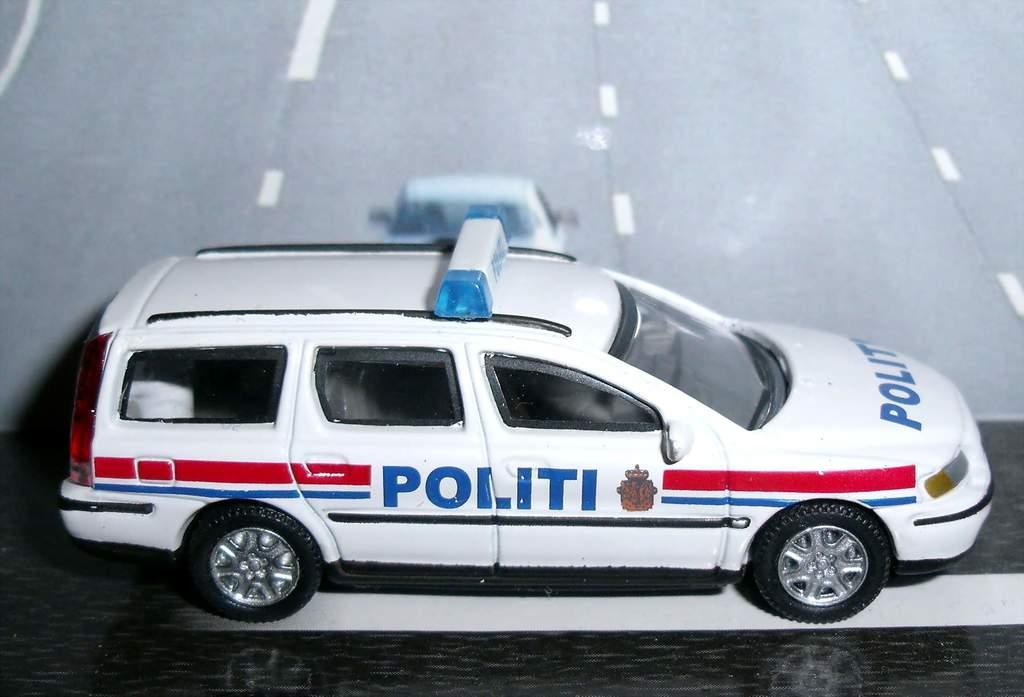What is the main subject in the center of the image? There is a toy car in the center of the image. What type of surface is at the bottom of the image? There is a floor at the bottom of the image. What can be seen in the background of the image? There is a road visible in the background of the image. What is the condition of the gold in the image? There is no gold present in the image. How does the lift function in the image? There is no lift present in the image. 